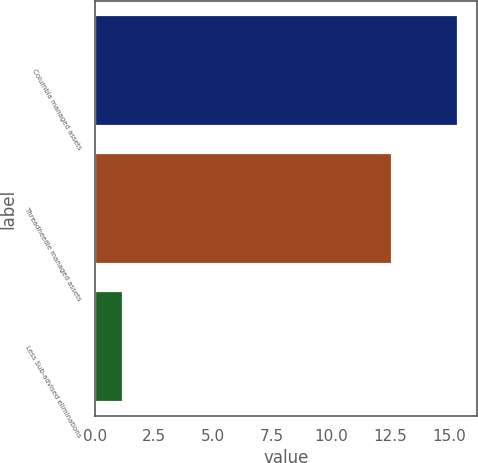<chart> <loc_0><loc_0><loc_500><loc_500><bar_chart><fcel>Columbia managed assets<fcel>Threadneedle managed assets<fcel>Less Sub-advised eliminations<nl><fcel>15.4<fcel>12.6<fcel>1.2<nl></chart> 